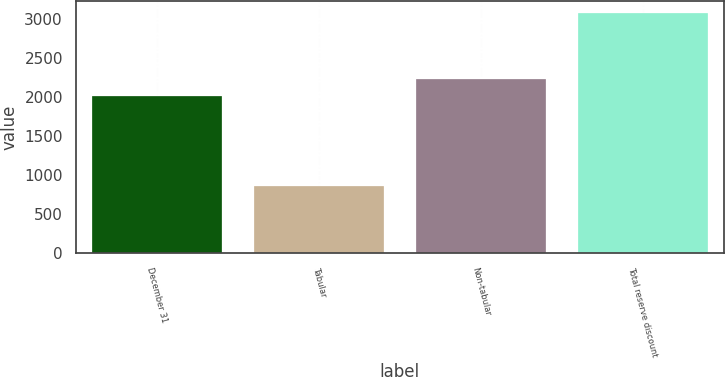Convert chart. <chart><loc_0><loc_0><loc_500><loc_500><bar_chart><fcel>December 31<fcel>Tabular<fcel>Non-tabular<fcel>Total reserve discount<nl><fcel>2014<fcel>852<fcel>2236.5<fcel>3077<nl></chart> 